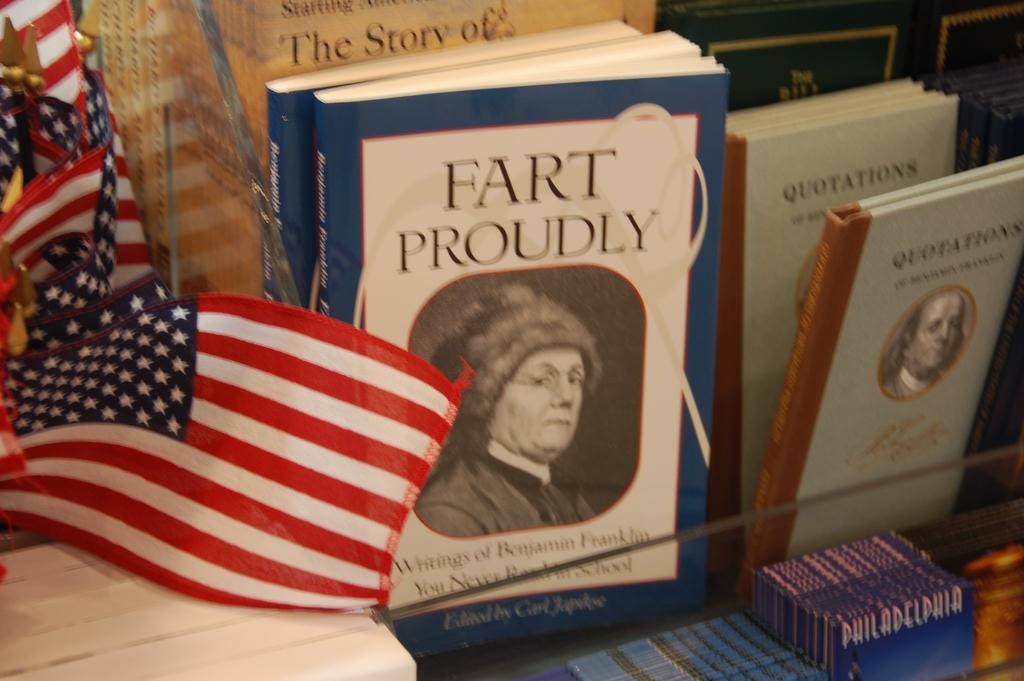Provide a one-sentence caption for the provided image. A book titled, "Fart Proudly" is next to miniature American flags. 